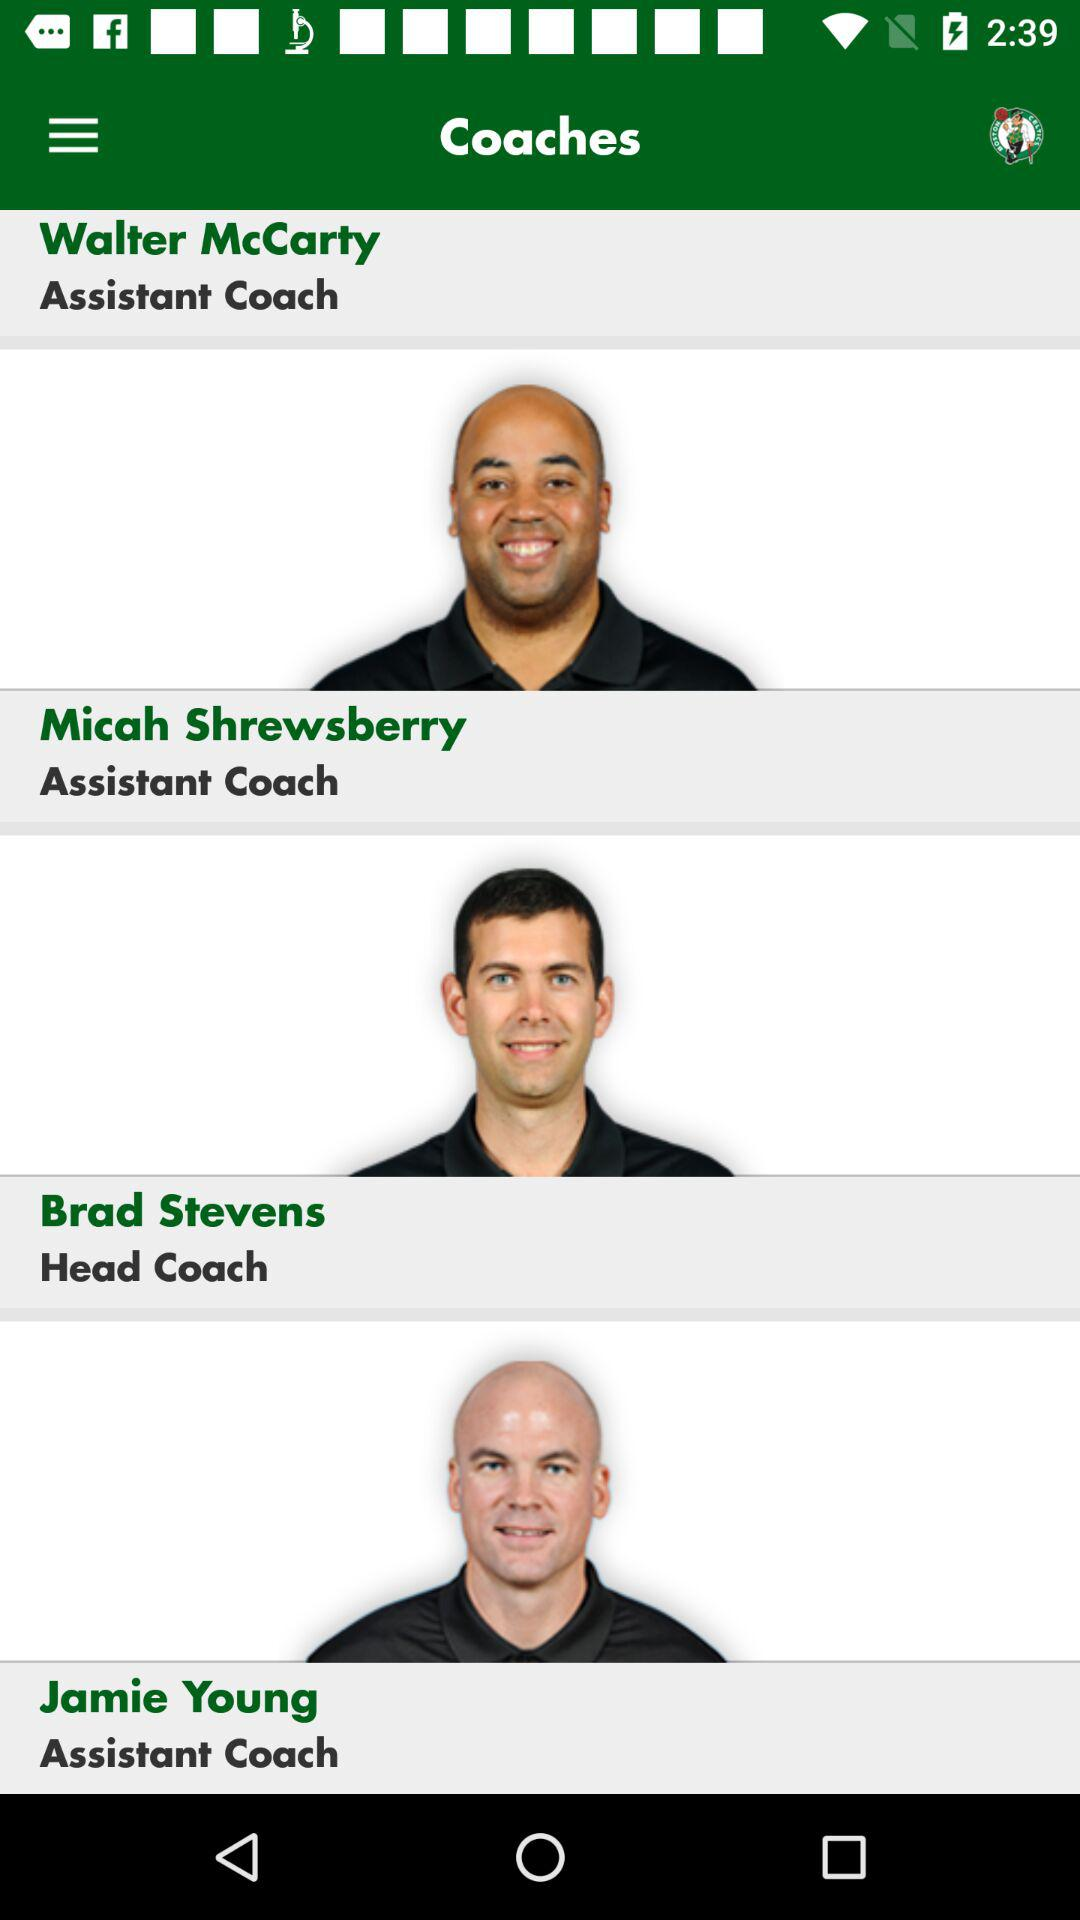What is the designation of Brad Stevens? The designation of Brad Stevens is "Head Coach". 